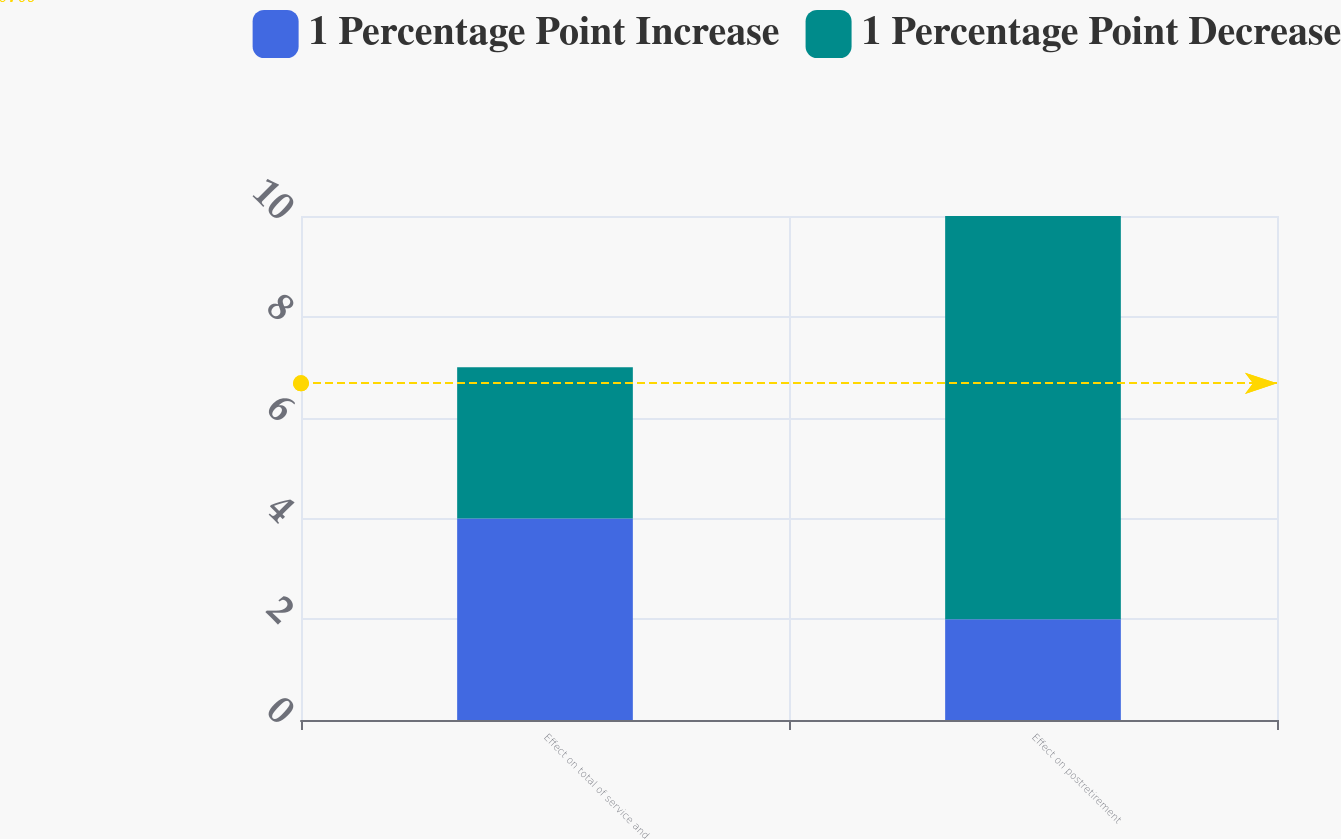Convert chart. <chart><loc_0><loc_0><loc_500><loc_500><stacked_bar_chart><ecel><fcel>Effect on total of service and<fcel>Effect on postretirement<nl><fcel>1 Percentage Point Increase<fcel>4<fcel>2<nl><fcel>1 Percentage Point Decrease<fcel>3<fcel>8<nl></chart> 